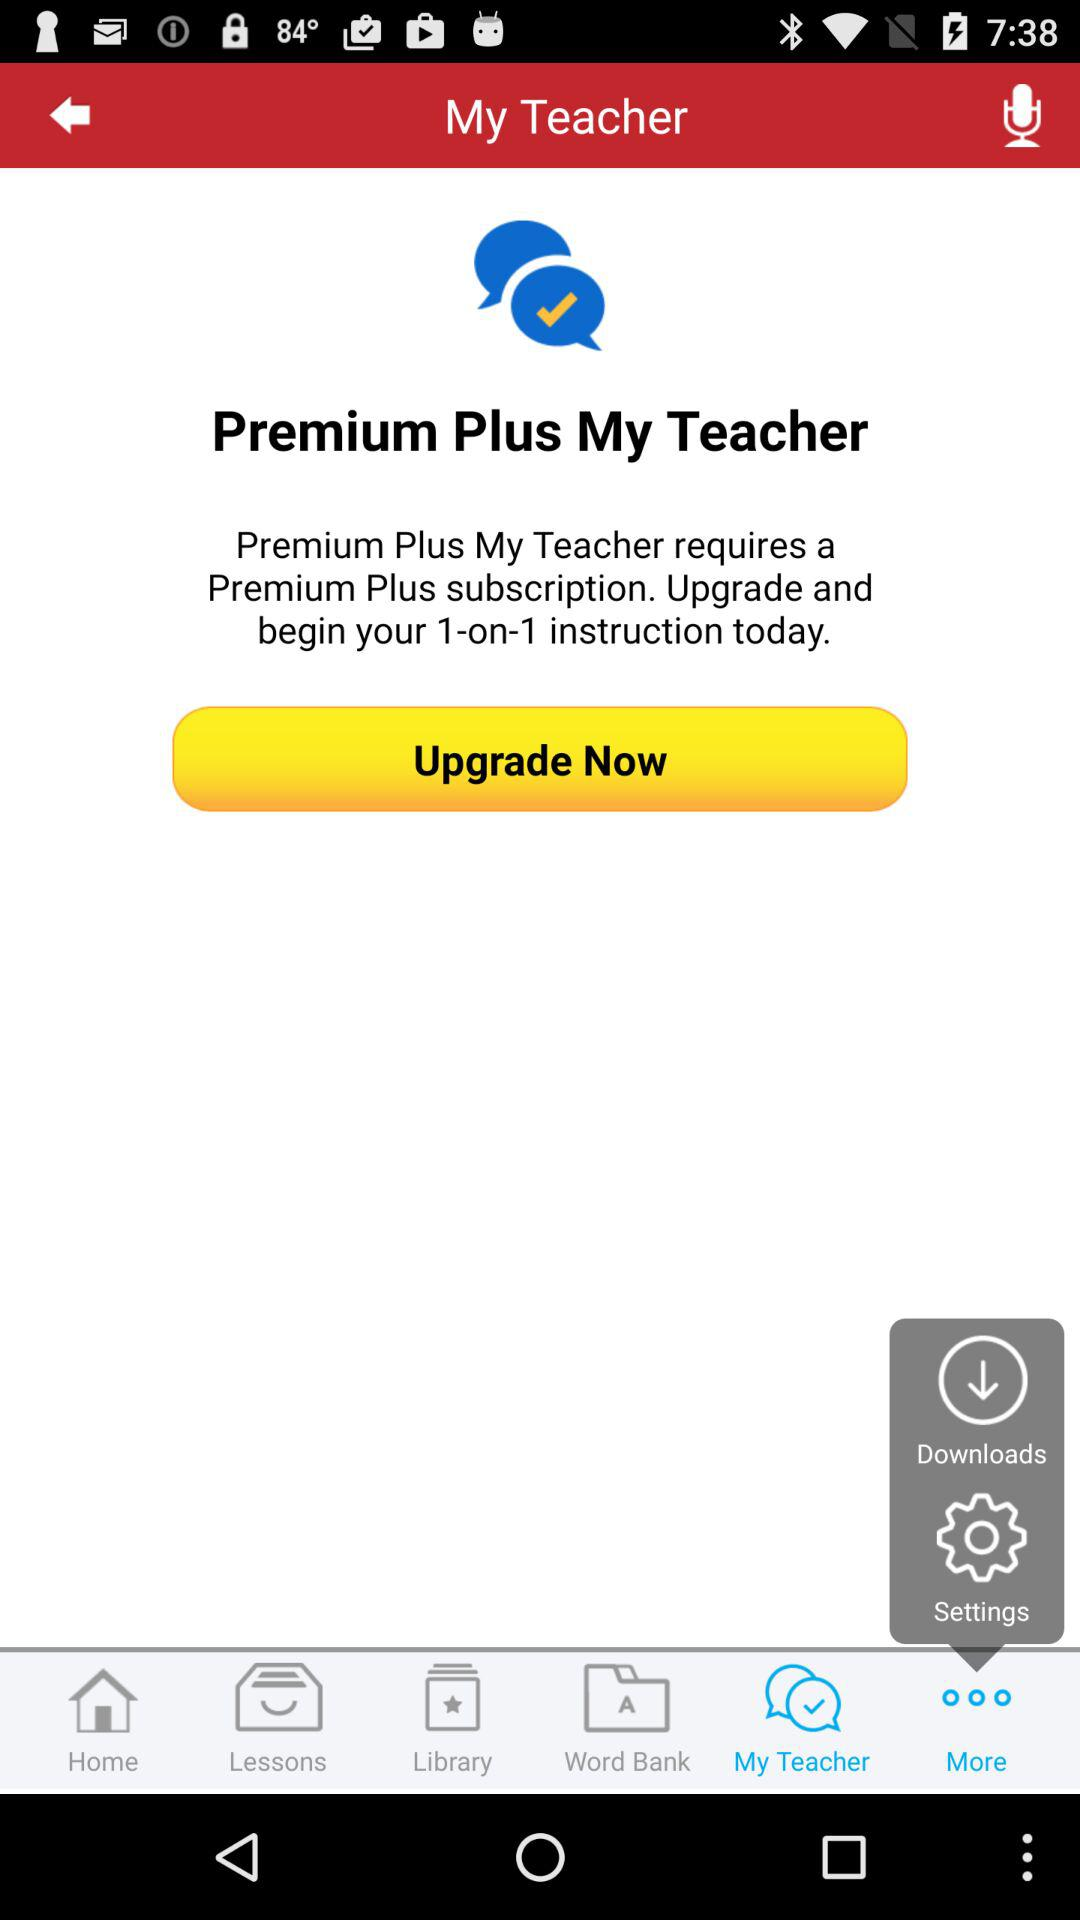Which tab is selected? The selected tab is "My Teacher". 